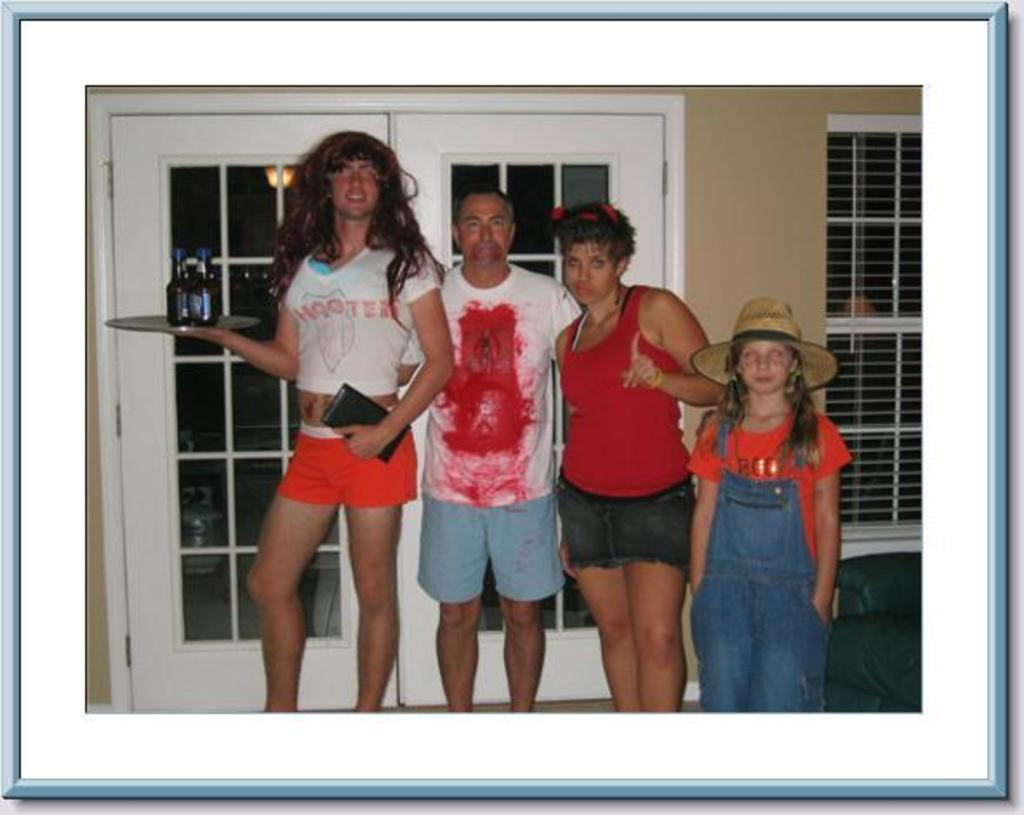<image>
Provide a brief description of the given image. a family photo where one guy is wearing aHooters outfit 